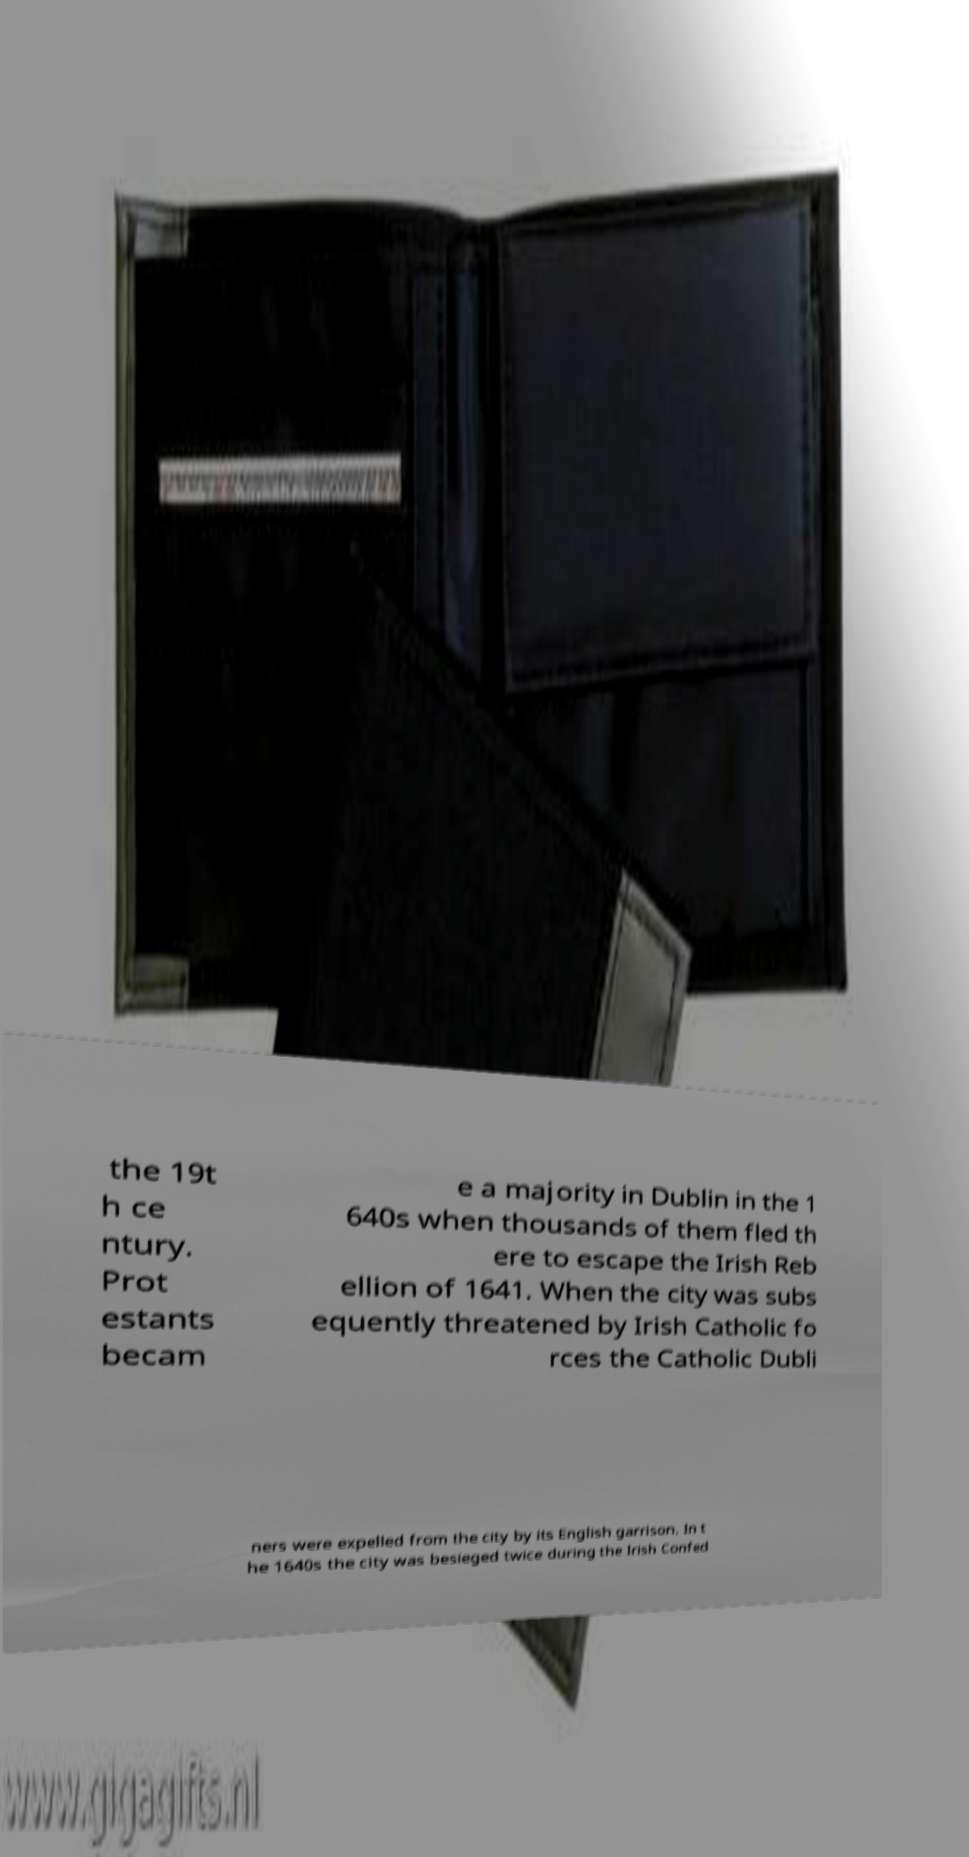Please read and relay the text visible in this image. What does it say? the 19t h ce ntury. Prot estants becam e a majority in Dublin in the 1 640s when thousands of them fled th ere to escape the Irish Reb ellion of 1641. When the city was subs equently threatened by Irish Catholic fo rces the Catholic Dubli ners were expelled from the city by its English garrison. In t he 1640s the city was besieged twice during the Irish Confed 